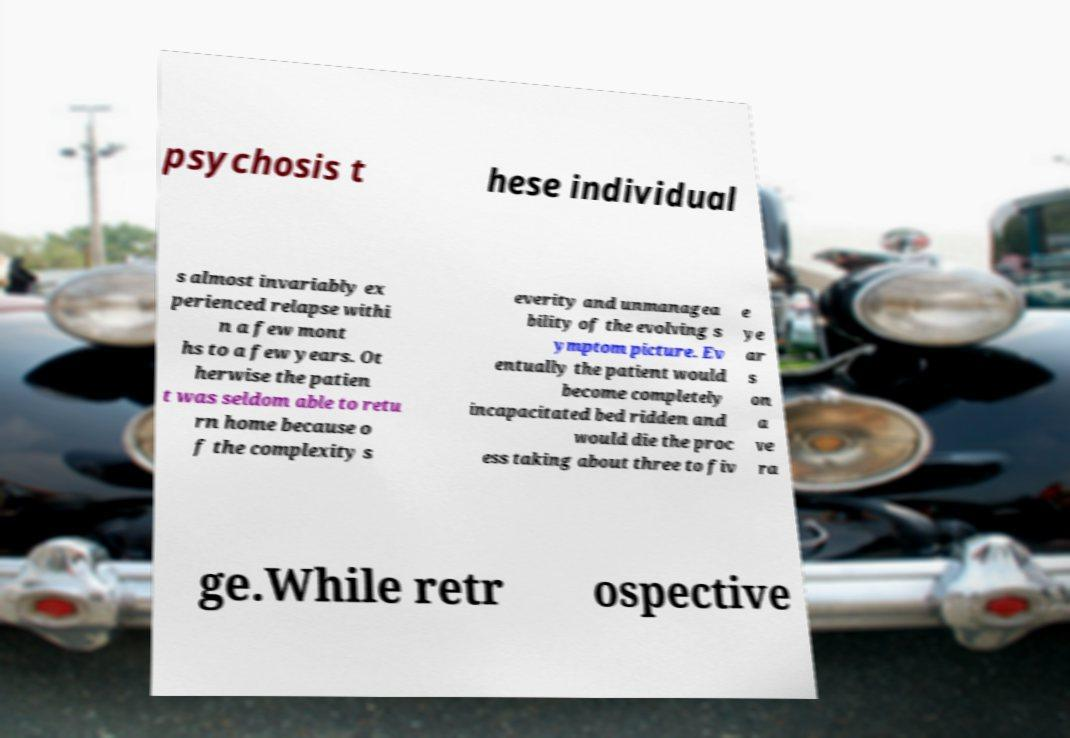Please identify and transcribe the text found in this image. psychosis t hese individual s almost invariably ex perienced relapse withi n a few mont hs to a few years. Ot herwise the patien t was seldom able to retu rn home because o f the complexity s everity and unmanagea bility of the evolving s ymptom picture. Ev entually the patient would become completely incapacitated bed ridden and would die the proc ess taking about three to fiv e ye ar s on a ve ra ge.While retr ospective 